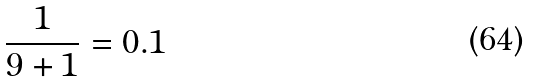<formula> <loc_0><loc_0><loc_500><loc_500>\frac { 1 } { 9 + 1 } = 0 . 1</formula> 